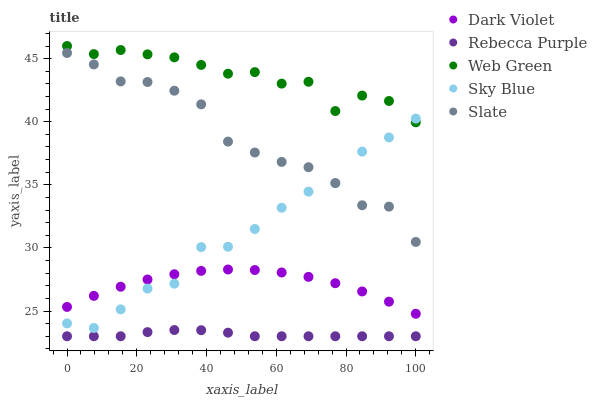Does Rebecca Purple have the minimum area under the curve?
Answer yes or no. Yes. Does Web Green have the maximum area under the curve?
Answer yes or no. Yes. Does Slate have the minimum area under the curve?
Answer yes or no. No. Does Slate have the maximum area under the curve?
Answer yes or no. No. Is Rebecca Purple the smoothest?
Answer yes or no. Yes. Is Sky Blue the roughest?
Answer yes or no. Yes. Is Slate the smoothest?
Answer yes or no. No. Is Slate the roughest?
Answer yes or no. No. Does Rebecca Purple have the lowest value?
Answer yes or no. Yes. Does Slate have the lowest value?
Answer yes or no. No. Does Web Green have the highest value?
Answer yes or no. Yes. Does Slate have the highest value?
Answer yes or no. No. Is Dark Violet less than Web Green?
Answer yes or no. Yes. Is Slate greater than Dark Violet?
Answer yes or no. Yes. Does Dark Violet intersect Sky Blue?
Answer yes or no. Yes. Is Dark Violet less than Sky Blue?
Answer yes or no. No. Is Dark Violet greater than Sky Blue?
Answer yes or no. No. Does Dark Violet intersect Web Green?
Answer yes or no. No. 